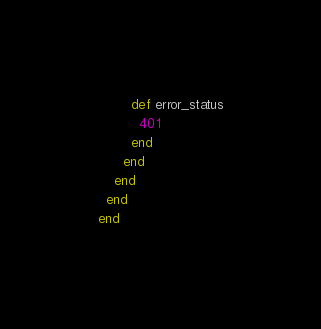Convert code to text. <code><loc_0><loc_0><loc_500><loc_500><_Ruby_>
        def error_status
          401
        end
      end
    end
  end
end
</code> 